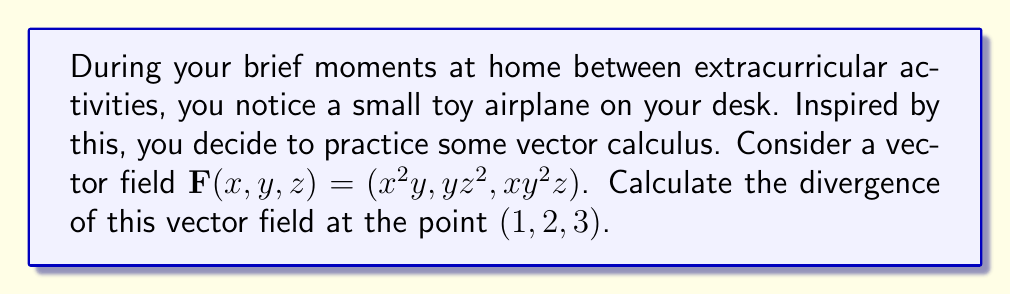Show me your answer to this math problem. Let's approach this step-by-step:

1) The divergence of a vector field $\mathbf{F}(x,y,z) = (F_1, F_2, F_3)$ in 3D space is given by:

   $$\text{div}\mathbf{F} = \nabla \cdot \mathbf{F} = \frac{\partial F_1}{\partial x} + \frac{\partial F_2}{\partial y} + \frac{\partial F_3}{\partial z}$$

2) In our case, we have:
   $F_1 = x^2y$
   $F_2 = yz^2$
   $F_3 = xy^2z$

3) Let's calculate each partial derivative:

   $\frac{\partial F_1}{\partial x} = \frac{\partial}{\partial x}(x^2y) = 2xy$

   $\frac{\partial F_2}{\partial y} = \frac{\partial}{\partial y}(yz^2) = z^2$

   $\frac{\partial F_3}{\partial z} = \frac{\partial}{\partial z}(xy^2z) = xy^2$

4) Now, we sum these partial derivatives:

   $$\text{div}\mathbf{F} = 2xy + z^2 + xy^2$$

5) Finally, we evaluate this at the point $(1,2,3)$:

   $$\text{div}\mathbf{F}(1,2,3) = 2(1)(2) + 3^2 + 1(2^2)(3) = 4 + 9 + 12 = 25$$
Answer: $25$ 